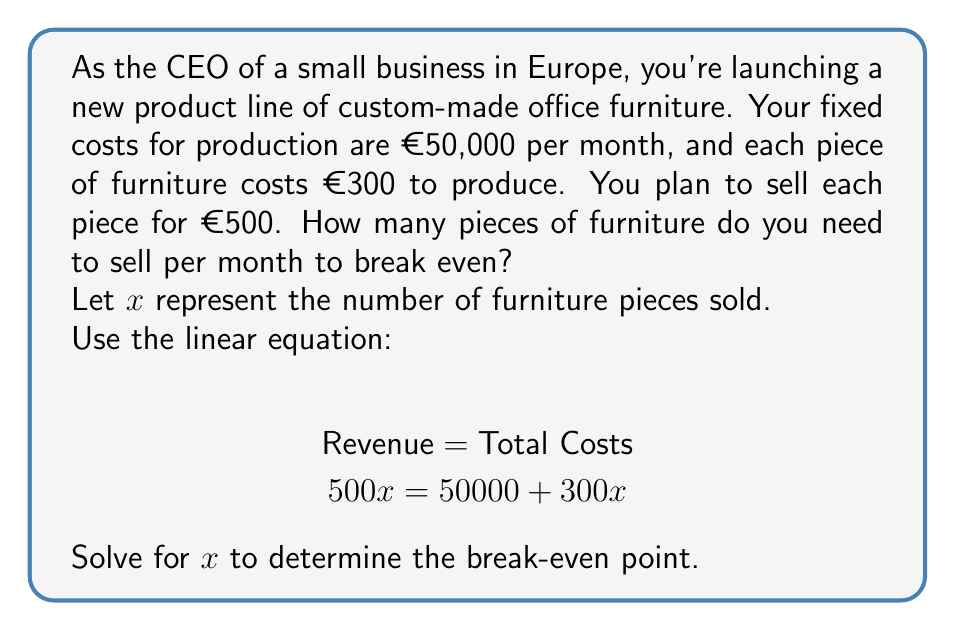Can you solve this math problem? To solve this problem, we'll use the break-even formula where revenue equals total costs. Let's break it down step-by-step:

1. Set up the equation:
   $$500x = 50000 + 300x$$

2. Subtract $300x$ from both sides:
   $$500x - 300x = 50000 + 300x - 300x$$
   $$200x = 50000$$

3. Divide both sides by 200:
   $$\frac{200x}{200} = \frac{50000}{200}$$
   $$x = 250$$

The break-even point occurs when 250 pieces of furniture are sold.

To verify:
Revenue: $500 \times 250 = €125,000$
Total Costs: $50000 + (300 \times 250) = €125,000$

At 250 pieces, revenue equals total costs, confirming the break-even point.
Answer: The break-even point is 250 pieces of furniture per month. 